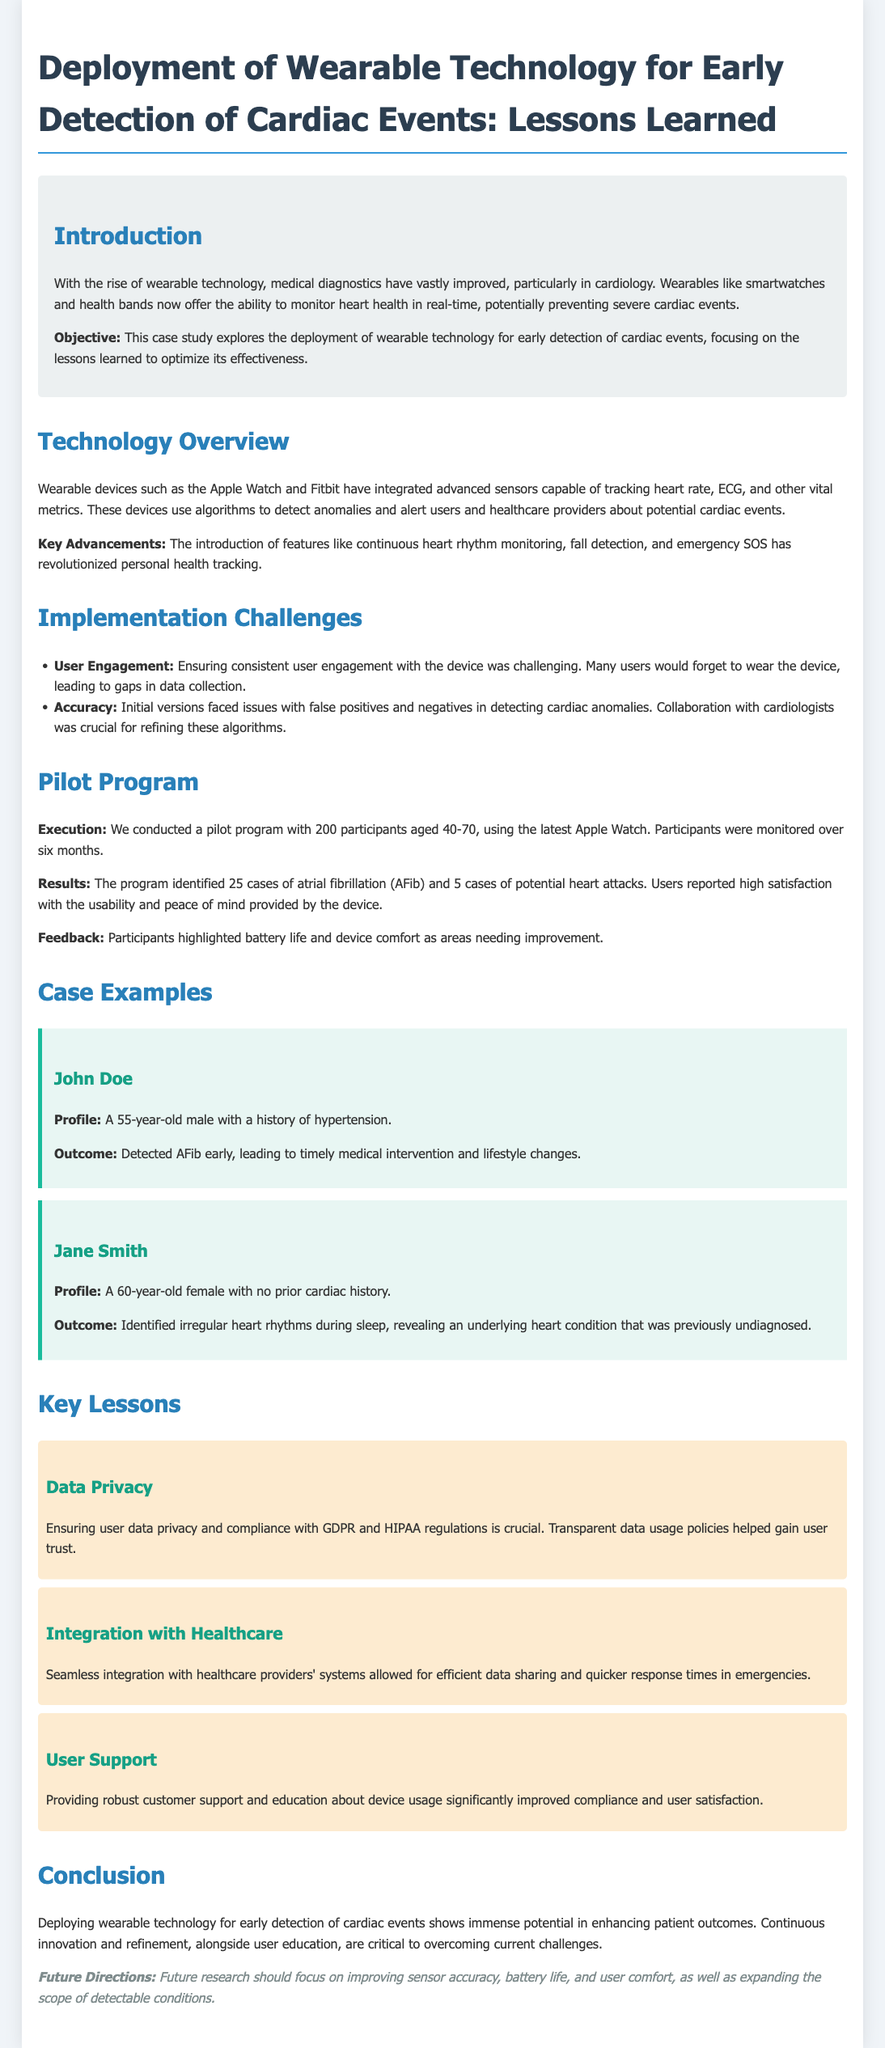What is the main objective of the case study? The case study aims to explore the deployment of wearable technology for early detection of cardiac events and focuses on the lessons learned to optimize its effectiveness.
Answer: early detection of cardiac events What challenges were faced regarding user engagement? The document states that ensuring consistent user engagement with the device was challenging, as many users would forget to wear it, leading to data collection gaps.
Answer: user engagement How many participants were in the pilot program? The pilot program involved a total of 200 participants aged 40-70.
Answer: 200 What condition was detected in John Doe? The document mentions that John Doe's AFib was detected early, leading to timely intervention.
Answer: AFib What was a key lesson learned about data privacy? The case study highlights the importance of ensuring user data privacy and compliance with GDPR and HIPAA regulations for gaining user trust.
Answer: user data privacy What technology was used in the pilot program? The pilot program utilized the latest Apple Watch for monitoring participants.
Answer: Apple Watch How many cases of atrial fibrillation were identified? According to the results mentioned, the program identified 25 cases of atrial fibrillation (AFib).
Answer: 25 Which female participant had no prior cardiac history? The document states that Jane Smith, a 60-year-old female, had no prior cardiac history before detection.
Answer: Jane Smith What aspect of user experience needed improvement according to feedback? Participants highlighted battery life and device comfort as areas needing improvement.
Answer: battery life and device comfort 